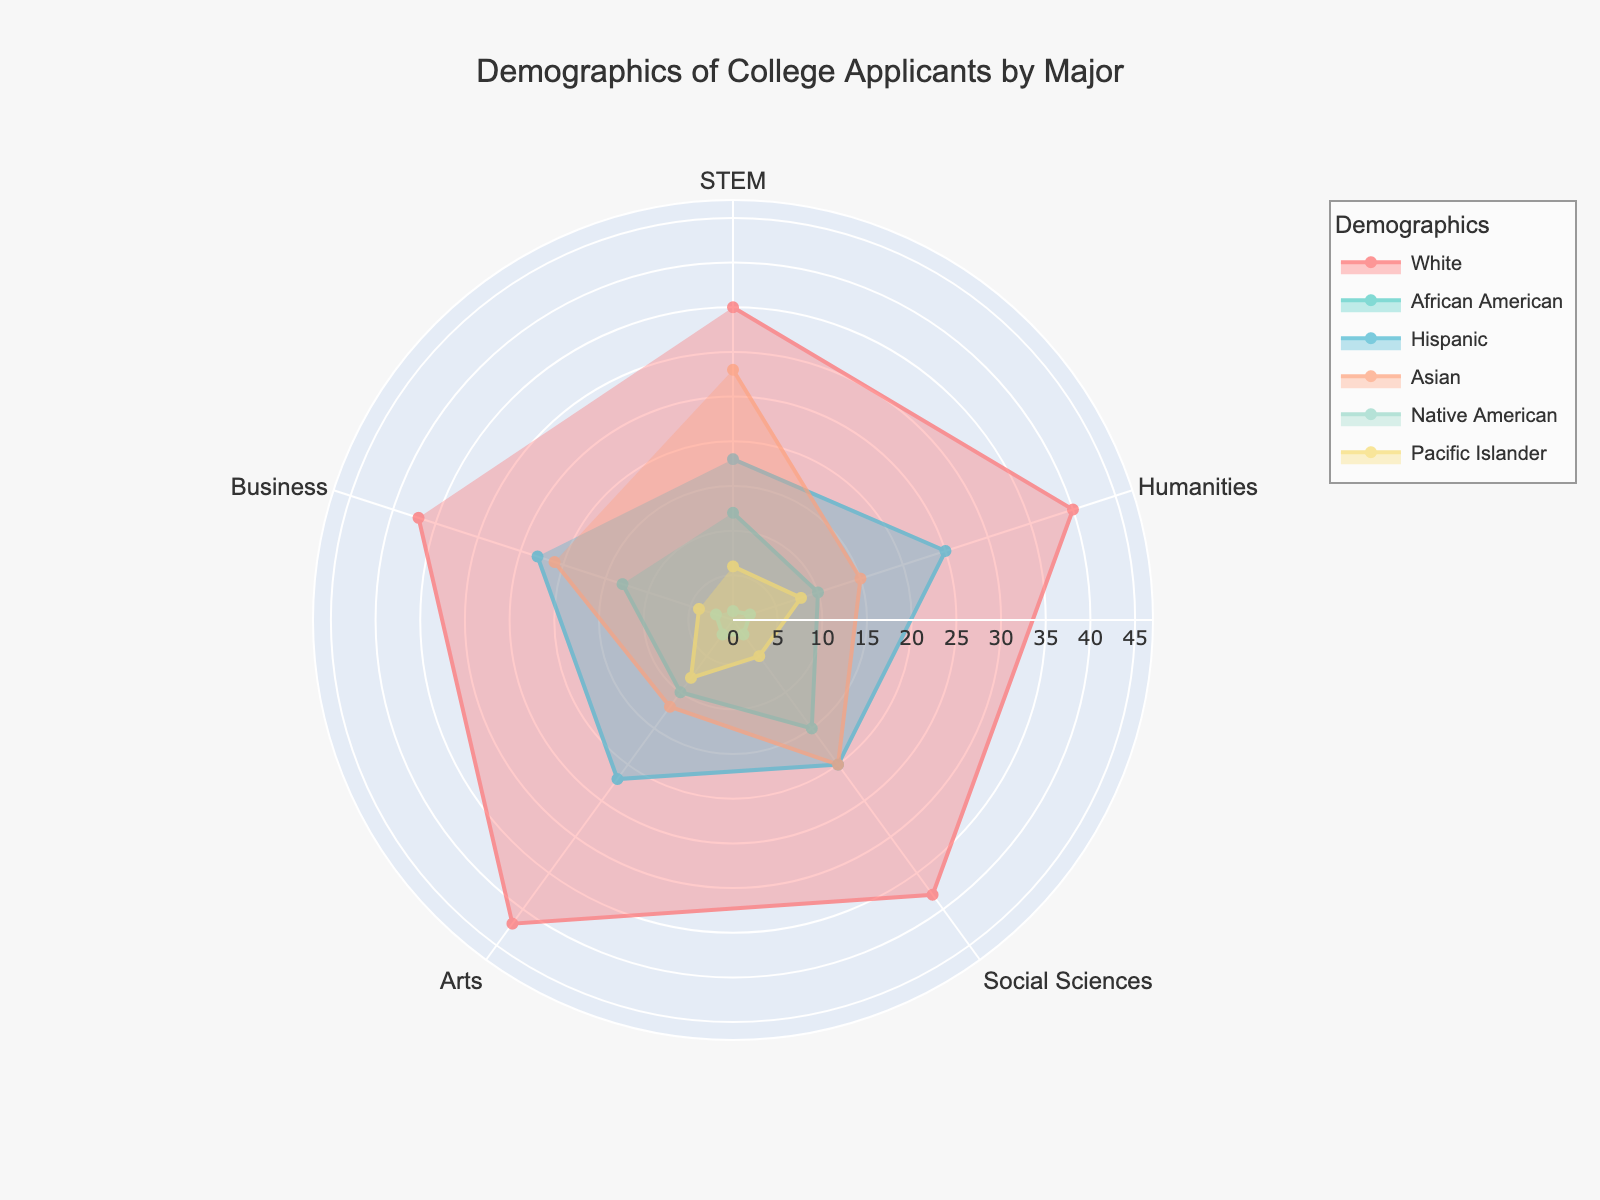Which major has the highest percentage of White applicants? First, identify the percentage of White applicants for each major: STEM (35%), Humanities (40%), Social Sciences (38%), Arts (42%), and Business (37%). The Arts major has the highest percentage at 42%.
Answer: Arts What is the percentage difference in Hispanic applicants between Humanities and STEM? Identify the percentage of Hispanic applicants in Humanities (25%) and STEM (18%). Subtract the percentage in STEM from Humanities: 25% - 18% = 7%.
Answer: 7% Which demographic has the highest representation in Social Sciences? List the percentages in Social Sciences for each demographic: White (38%), African American (15%), Hispanic (20%), Asian (20%), Native American (2%), Pacific Islander (5%). The White demographic has the highest representation at 38%.
Answer: White How does the percentage of Asian applicants in STEM compare to that in Humanities? Identify the percentage of Asian applicants in STEM (28%) and Humanities (15%). Compare the two: 28% is higher than 15%.
Answer: STEM has a higher percentage of Asian applicants Which major has the lowest percentage of Native American applicants? List the percentages of Native American applicants in each major: STEM (1%), Humanities (2%), Social Sciences (2%), Arts (2%), Business (2%). STEM has the lowest percentage at 1%.
Answer: STEM What is the average percentage of African American applicants across all majors? Calculate the total percentage of African American applicants across all majors: 12% (STEM) + 10% (Humanities) + 15% (Social Sciences) + 10% (Arts) + 13% (Business) = 60%. Divide by 5 (number of majors): 60% / 5 = 12%.
Answer: 12% Among all the demographics, which one shows the lowest representation in any major? Identify the minimum percentage in each demographic across all majors: White (35% STEM), African American (10% Humanities/Arts), Hispanic (18% STEM), Asian (12% Arts), Native American (1% STEM), Pacific Islander (4% Business). The lowest representation is for Native American in STEM at 1%.
Answer: Native American in STEM What is the range of Pacific Islander applicants' percentage across all majors? Identify the minimum (4% Business) and maximum (8% Humanities/Arts) percentages of Pacific Islander applicants across all majors. Calculate the range: 8% - 4% = 4%.
Answer: 4% 